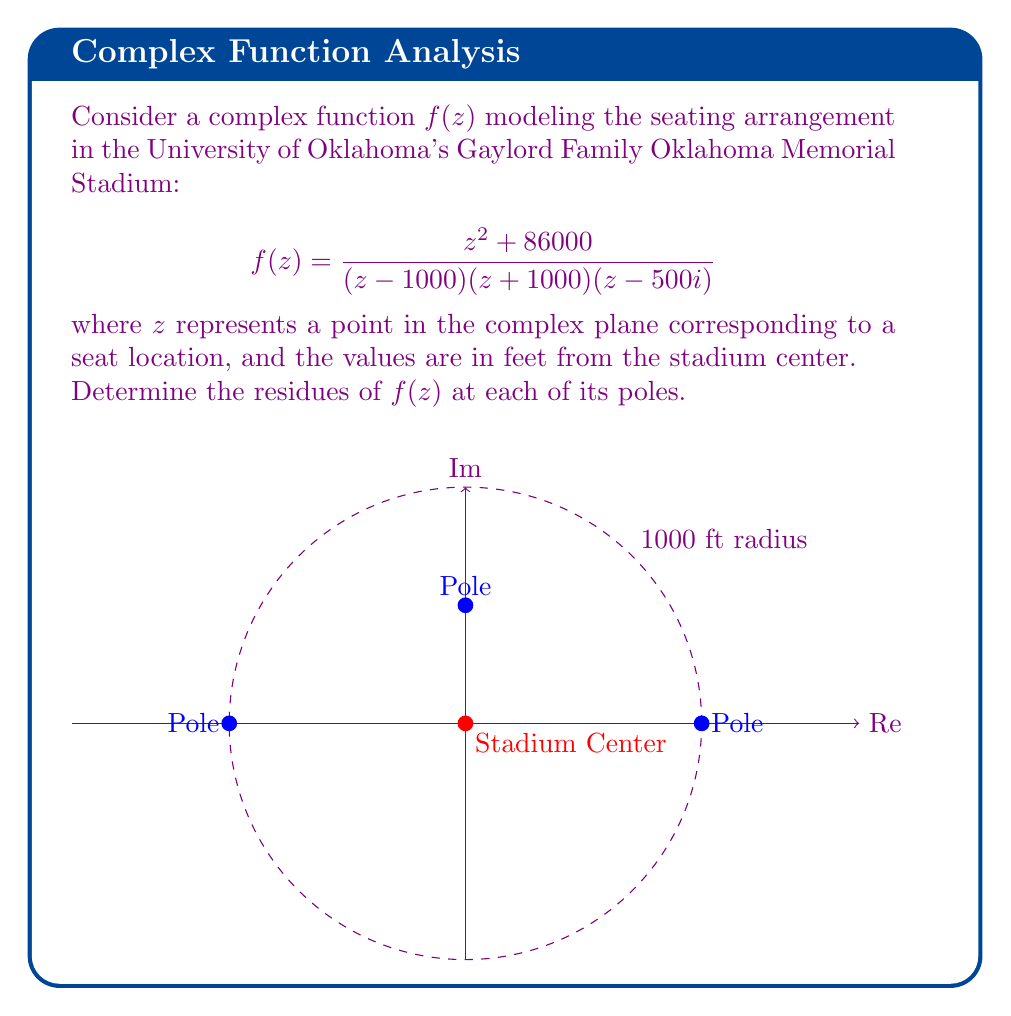Give your solution to this math problem. Let's approach this step-by-step:

1) The function $f(z)$ has three poles:
   $z_1 = 1000$, $z_2 = -1000$, and $z_3 = 500i$

2) To find the residues, we'll use the formula for simple poles:
   $\text{Res}(f,a) = \lim_{z \to a} (z-a)f(z)$

3) For $z_1 = 1000$:
   $$\begin{align*}
   \text{Res}(f,1000) &= \lim_{z \to 1000} (z-1000)\frac{z^2 + 86000}{(z - 1000)(z + 1000)(z - 500i)} \\
   &= \lim_{z \to 1000} \frac{z^2 + 86000}{(z + 1000)(z - 500i)} \\
   &= \frac{1000^2 + 86000}{(2000)(1000 - 500i)} \\
   &= \frac{1086000}{2000000 - 1000000i} \\
   &= \frac{543}{1000 - 500i}
   \end{align*}$$

4) For $z_2 = -1000$:
   $$\begin{align*}
   \text{Res}(f,-1000) &= \lim_{z \to -1000} (z+1000)\frac{z^2 + 86000}{(z - 1000)(z + 1000)(z - 500i)} \\
   &= \lim_{z \to -1000} \frac{z^2 + 86000}{(z - 1000)(z - 500i)} \\
   &= \frac{(-1000)^2 + 86000}{(-2000)(-1000 - 500i)} \\
   &= \frac{1086000}{-2000000 - 1000000i} \\
   &= -\frac{543}{1000 + 500i}
   \end{align*}$$

5) For $z_3 = 500i$:
   $$\begin{align*}
   \text{Res}(f,500i) &= \lim_{z \to 500i} (z-500i)\frac{z^2 + 86000}{(z - 1000)(z + 1000)(z - 500i)} \\
   &= \lim_{z \to 500i} \frac{z^2 + 86000}{(z - 1000)(z + 1000)} \\
   &= \frac{(500i)^2 + 86000}{(500i - 1000)(500i + 1000)} \\
   &= \frac{-250000 + 86000}{-750000 - 1250000i} \\
   &= \frac{164}{1500 + 2500i}
   \end{align*}$$
Answer: $\text{Res}(f,1000) = \frac{543}{1000 - 500i}$, $\text{Res}(f,-1000) = -\frac{543}{1000 + 500i}$, $\text{Res}(f,500i) = \frac{164}{1500 + 2500i}$ 